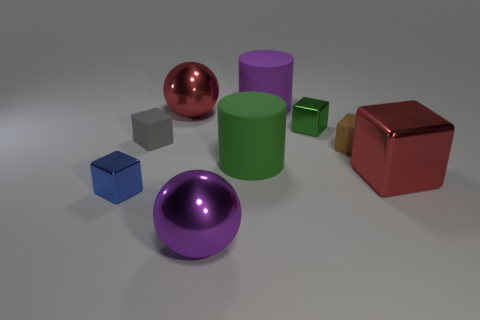What number of other blocks are the same color as the big metal block?
Offer a very short reply. 0. What number of objects are objects that are to the left of the big green cylinder or shiny cubes that are on the right side of the tiny blue metal cube?
Provide a short and direct response. 6. Is the number of green matte objects greater than the number of tiny metal objects?
Make the answer very short. No. What color is the tiny shiny thing that is right of the tiny gray matte thing?
Ensure brevity in your answer.  Green. Is the shape of the big green thing the same as the big purple matte object?
Keep it short and to the point. Yes. What is the color of the block that is in front of the big green cylinder and right of the blue shiny block?
Keep it short and to the point. Red. Does the metal cube that is to the left of the big purple ball have the same size as the cylinder that is right of the green cylinder?
Offer a terse response. No. What number of objects are big red objects on the right side of the big purple rubber cylinder or large yellow rubber cubes?
Provide a succinct answer. 1. What is the material of the green cylinder?
Ensure brevity in your answer.  Rubber. Does the blue metallic object have the same size as the purple shiny thing?
Give a very brief answer. No. 